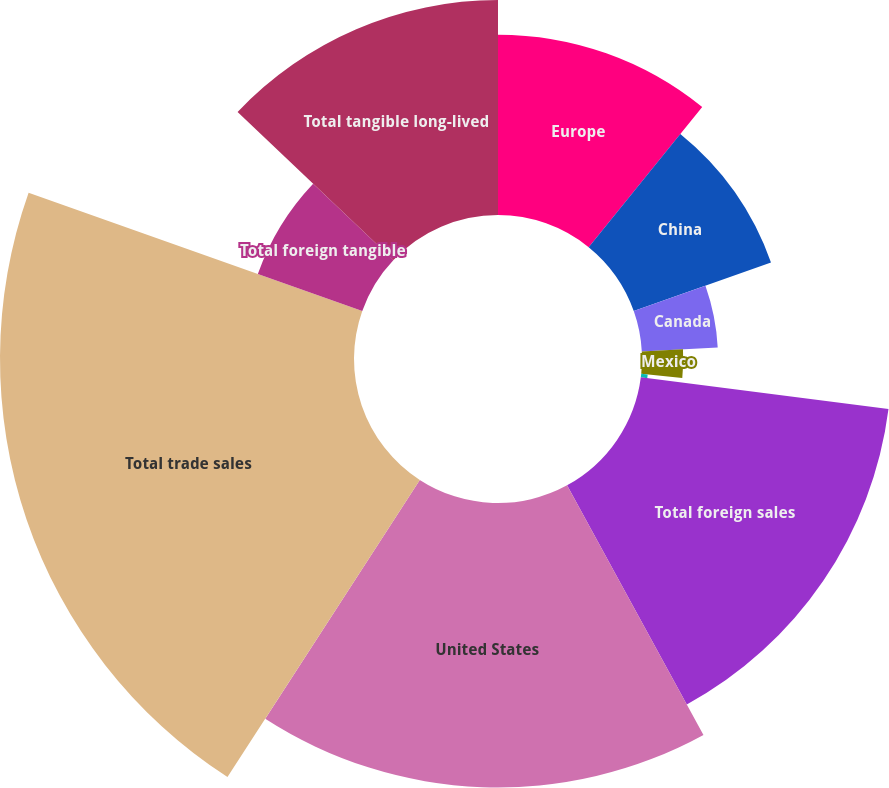<chart> <loc_0><loc_0><loc_500><loc_500><pie_chart><fcel>Europe<fcel>China<fcel>Canada<fcel>Mexico<fcel>Other<fcel>Total foreign sales<fcel>United States<fcel>Total trade sales<fcel>Total foreign tangible<fcel>Total tangible long-lived<nl><fcel>10.84%<fcel>8.75%<fcel>4.57%<fcel>2.48%<fcel>0.39%<fcel>15.01%<fcel>17.1%<fcel>21.28%<fcel>6.66%<fcel>12.92%<nl></chart> 